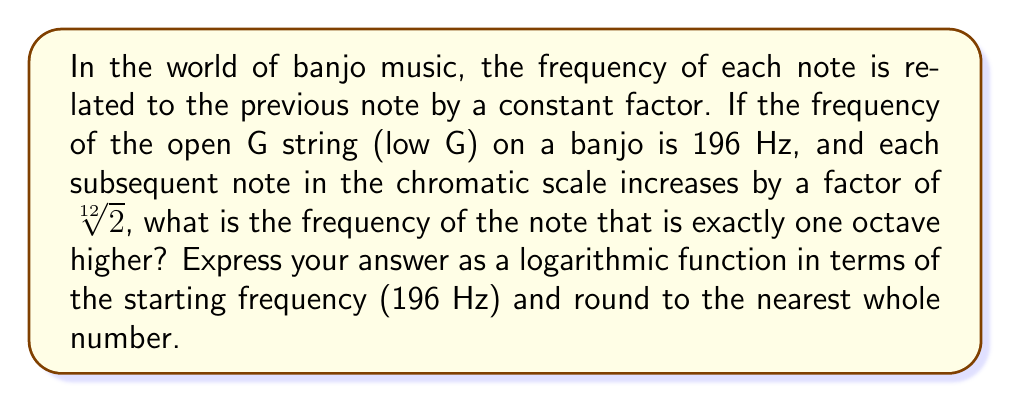Provide a solution to this math problem. Let's approach this step-by-step:

1) In music theory, an octave represents a doubling of frequency. So, we need to find the 12th note in the chromatic scale, as there are 12 semitones in an octave.

2) The relationship between each note can be expressed as:
   $$f_n = f_0 \cdot (\sqrt[12]{2})^n$$
   Where $f_n$ is the frequency of the nth note, and $f_0$ is the starting frequency.

3) We want the 12th note, so n = 12:
   $$f_{12} = 196 \cdot (\sqrt[12]{2})^{12}$$

4) Simplify the exponent:
   $$f_{12} = 196 \cdot (2)^1 = 196 \cdot 2 = 392$$

5) To express this as a logarithmic function:
   $$f_{12} = f_0 \cdot 2^{\log_2(2)} = f_0 \cdot 2^1 = f_0 \cdot 2$$

6) Therefore, the frequency of the note one octave higher can be expressed as:
   $$f = 196 \cdot 2^1 = 392\text{ Hz}$$

Rounding to the nearest whole number isn't necessary in this case as the result is already a whole number.
Answer: $f = f_0 \cdot 2^1 = 392\text{ Hz}$ 